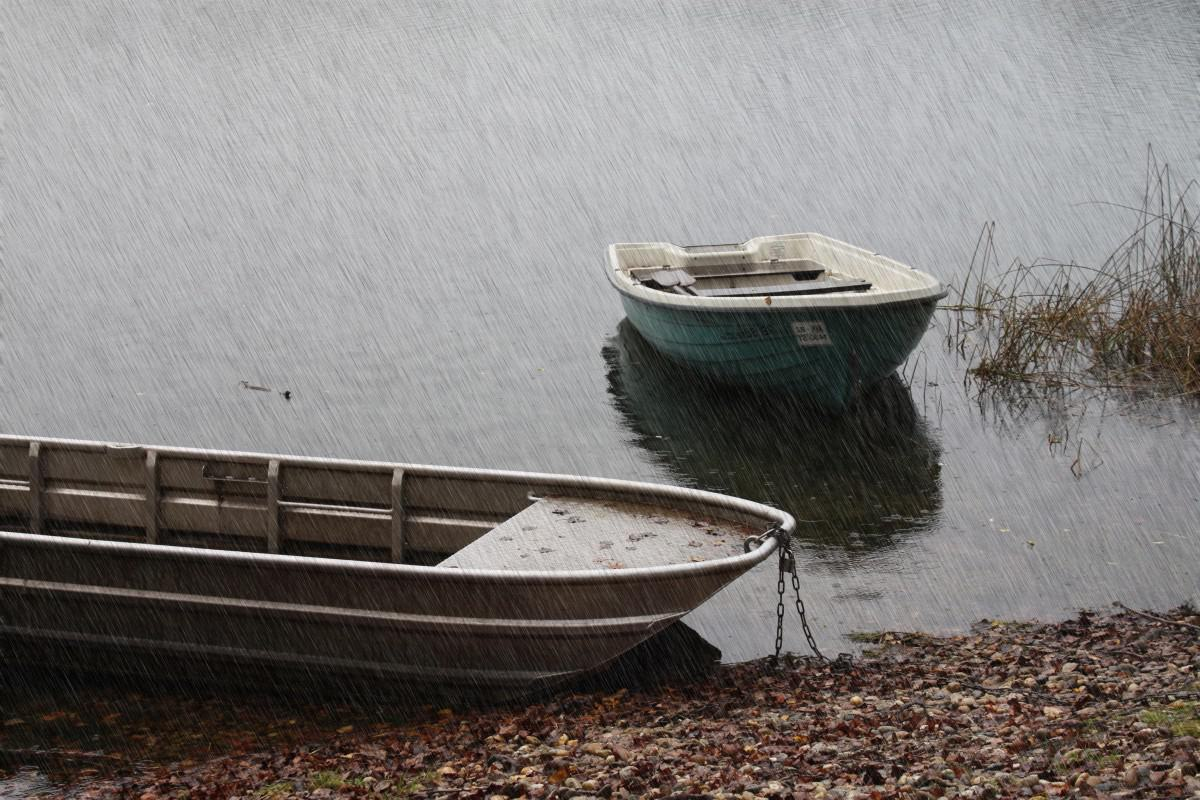What time of day does it seem to be? Due to the overcast sky and lack of visible shadows, it's difficult to determine the exact time of day. It could be midday with heavy cloud cover, or it could be early morning or late afternoon when the light is generally softer. 